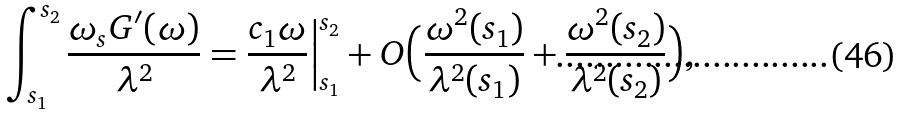<formula> <loc_0><loc_0><loc_500><loc_500>\int _ { s _ { 1 } } ^ { s _ { 2 } } \frac { \omega _ { s } G ^ { \prime } ( \omega ) } { \lambda ^ { 2 } } = \frac { c _ { 1 } \omega } { \lambda ^ { 2 } } \Big | _ { s _ { 1 } } ^ { s _ { 2 } } + O \Big ( \frac { \omega ^ { 2 } ( s _ { 1 } ) } { \lambda ^ { 2 } ( s _ { 1 } ) } + \frac { \omega ^ { 2 } ( s _ { 2 } ) } { \lambda ^ { 2 } ( s _ { 2 } ) } \Big ) ,</formula> 